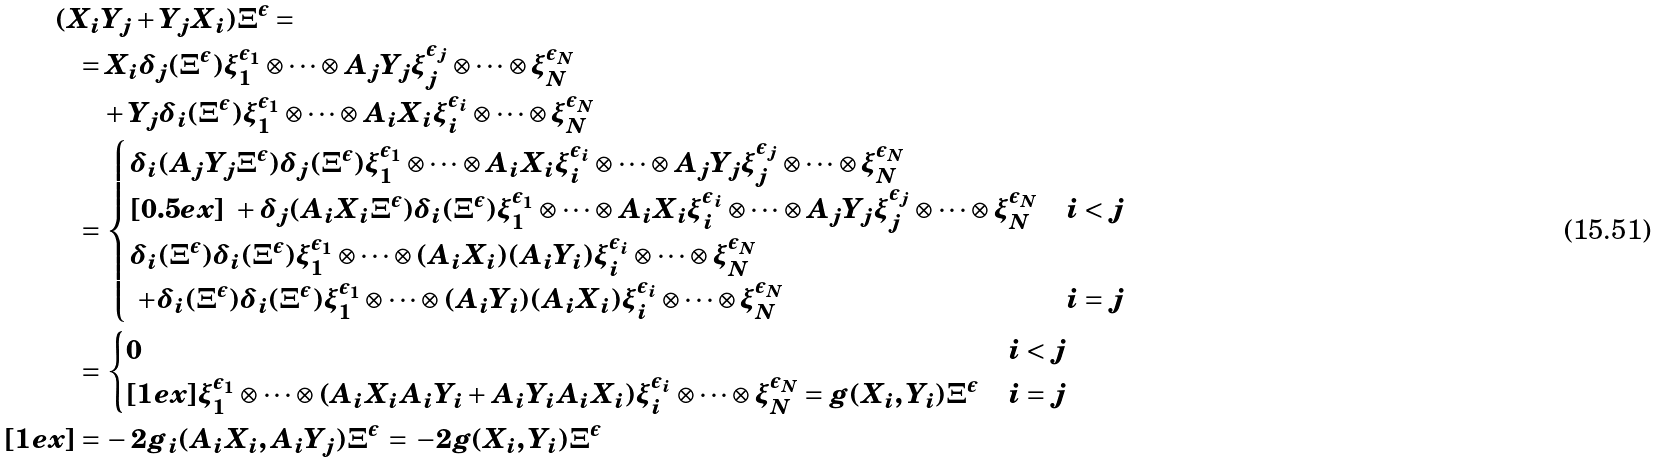<formula> <loc_0><loc_0><loc_500><loc_500>( X _ { i } & Y _ { j } + Y _ { j } X _ { i } ) \Xi ^ { \epsilon } = \\ = & \, X _ { i } \delta _ { j } ( \Xi ^ { \epsilon } ) \xi _ { 1 } ^ { \epsilon _ { 1 } } \otimes \cdots \otimes A _ { j } Y _ { j } \xi _ { j } ^ { \epsilon _ { j } } \otimes \cdots \otimes \xi _ { N } ^ { \epsilon _ { N } } \\ & + Y _ { j } \delta _ { i } ( \Xi ^ { \epsilon } ) \xi _ { 1 } ^ { \epsilon _ { 1 } } \otimes \cdots \otimes A _ { i } X _ { i } \xi _ { i } ^ { \epsilon _ { i } } \otimes \cdots \otimes \xi _ { N } ^ { \epsilon _ { N } } \\ = & \, \begin{cases} \delta _ { i } ( A _ { j } Y _ { j } \Xi ^ { \epsilon } ) \delta _ { j } ( \Xi ^ { \epsilon } ) \xi _ { 1 } ^ { \epsilon _ { 1 } } \otimes \cdots \otimes A _ { i } X _ { i } \xi ^ { \epsilon _ { i } } _ { i } \otimes \cdots \otimes A _ { j } Y _ { j } \xi _ { j } ^ { \epsilon _ { j } } \otimes \cdots \otimes \xi _ { N } ^ { \epsilon _ { N } } & \\ [ 0 . 5 e x ] \ + \delta _ { j } ( A _ { i } X _ { i } \Xi ^ { \epsilon } ) \delta _ { i } ( \Xi ^ { \epsilon } ) \xi _ { 1 } ^ { \epsilon _ { 1 } } \otimes \cdots \otimes A _ { i } X _ { i } \xi _ { i } ^ { \epsilon _ { i } } \otimes \cdots \otimes A _ { j } Y _ { j } \xi ^ { \epsilon _ { j } } _ { j } \otimes \cdots \otimes \xi _ { N } ^ { \epsilon _ { N } } & i < j \\ \delta _ { i } ( \Xi ^ { \epsilon } ) \delta _ { i } ( \Xi ^ { \epsilon } ) \xi _ { 1 } ^ { \epsilon _ { 1 } } \otimes \cdots \otimes ( A _ { i } X _ { i } ) ( A _ { i } Y _ { i } ) \xi _ { i } ^ { \epsilon _ { i } } \otimes \cdots \otimes \xi _ { N } ^ { \epsilon _ { N } } & \\ \ + \delta _ { i } ( \Xi ^ { \epsilon } ) \delta _ { i } ( \Xi ^ { \epsilon } ) \xi _ { 1 } ^ { \epsilon _ { 1 } } \otimes \cdots \otimes ( A _ { i } Y _ { i } ) ( A _ { i } X _ { i } ) \xi _ { i } ^ { \epsilon _ { i } } \otimes \cdots \otimes \xi _ { N } ^ { \epsilon _ { N } } & i = j \end{cases} \\ = & \, \begin{cases} 0 & i < j \\ [ 1 e x ] \xi _ { 1 } ^ { \epsilon _ { 1 } } \otimes \cdots \otimes ( A _ { i } X _ { i } A _ { i } Y _ { i } + A _ { i } Y _ { i } A _ { i } X _ { i } ) \xi _ { i } ^ { \epsilon _ { i } } \otimes \cdots \otimes \xi _ { N } ^ { \epsilon _ { N } } = g ( X _ { i } , Y _ { i } ) \Xi ^ { \epsilon } & i = j \end{cases} \\ [ 1 e x ] = & \, - 2 g _ { i } ( A _ { i } X _ { i } , A _ { i } Y _ { j } ) \Xi ^ { \epsilon } \, = \, - 2 g ( X _ { i } , Y _ { i } ) \Xi ^ { \epsilon }</formula> 